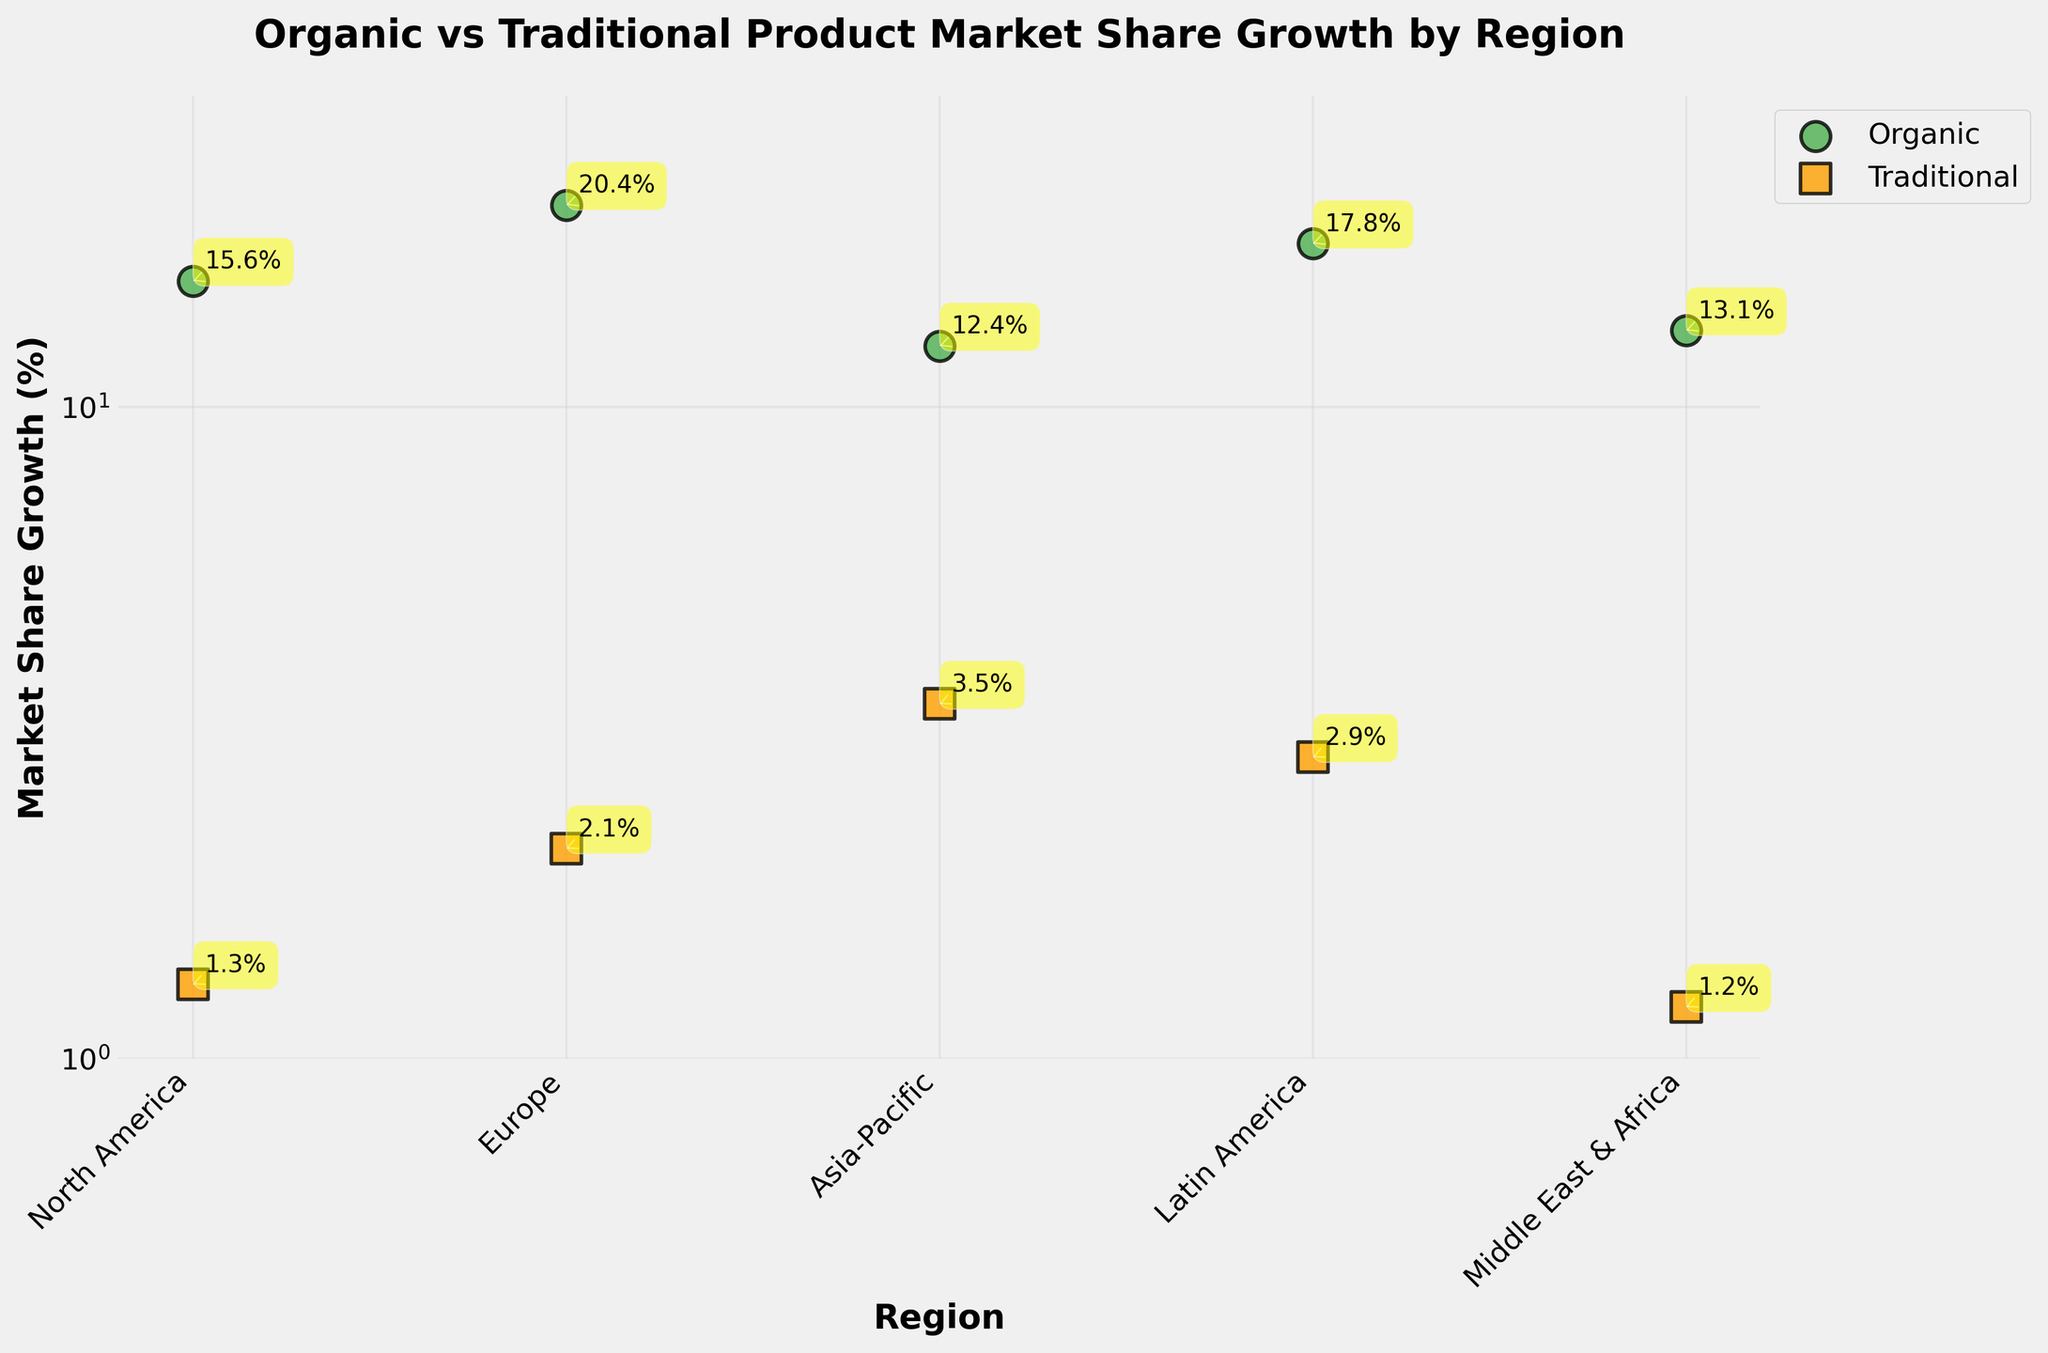What is the title of the figure? The title is usually found at the top of the figure.
Answer: Organic vs Traditional Product Market Share Growth by Region Which region shows the highest market share growth for organic products? By looking at the y-axis position of each 'o' marker, the highest one represents the highest market share growth for organic products.
Answer: Europe What is the market share growth percentage for traditional products in Asia-Pacific? Locate the 's' marker on the scatter plot in the Asia-Pacific region and read its y-axis value.
Answer: 3.5% Which product type has a higher market share growth in North America? Compare the y-axis positions of the 'o' marker (Organic) and 's' marker (Traditional) in North America.
Answer: Organic On average, how does the market share growth of organic products compare to traditional products across all regions? Calculate the average market share growth for organic products and for traditional products and compare the two values.
Answer: Higher for organic products Which region has the smallest difference between organic and traditional market share growth? For each region, subtract the market share growth of traditional from organic and find the smallest difference.
Answer: Middle East & Africa What is the range of the market share growth percentages shown in the figure? Identify the minimum and maximum y-axis values across all data points and find their range.
Answer: 1.2% to 20.4% How are the markers for organic and traditional products visually differentiated in the plot? Describe the visual elements (color, shape, etc.) used to differentiate between the two types of products in the scatter plot.
Answer: Organic (green circles) and Traditional (orange squares) 